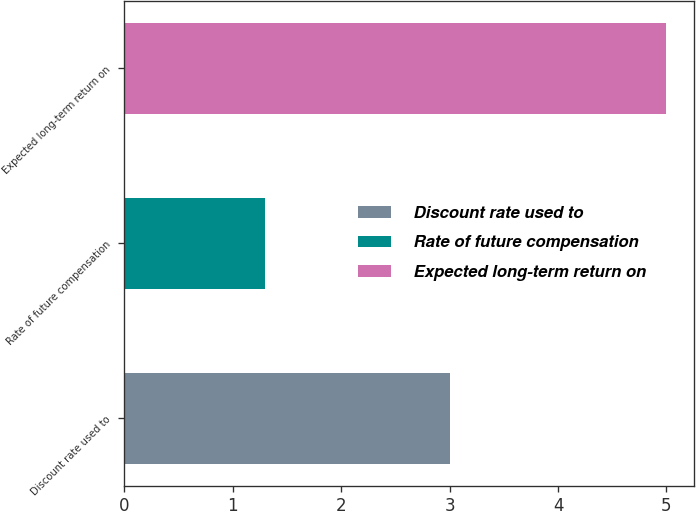<chart> <loc_0><loc_0><loc_500><loc_500><bar_chart><fcel>Discount rate used to<fcel>Rate of future compensation<fcel>Expected long-term return on<nl><fcel>3<fcel>1.3<fcel>5<nl></chart> 